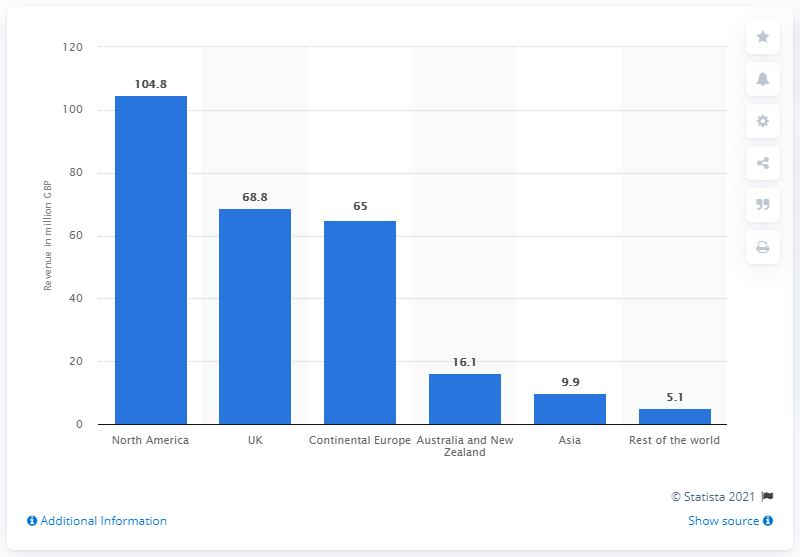Indicate a few pertinent items in this graphic. Games Workshop's revenue in North America in 2020 was £68.8 million. 